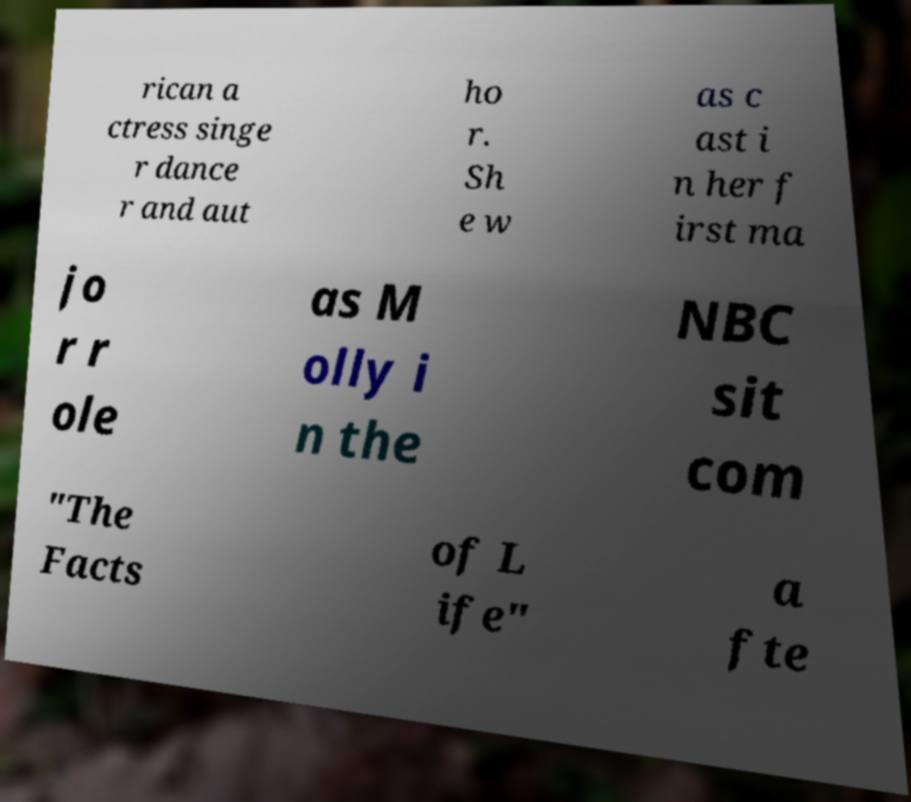Can you read and provide the text displayed in the image?This photo seems to have some interesting text. Can you extract and type it out for me? rican a ctress singe r dance r and aut ho r. Sh e w as c ast i n her f irst ma jo r r ole as M olly i n the NBC sit com "The Facts of L ife" a fte 